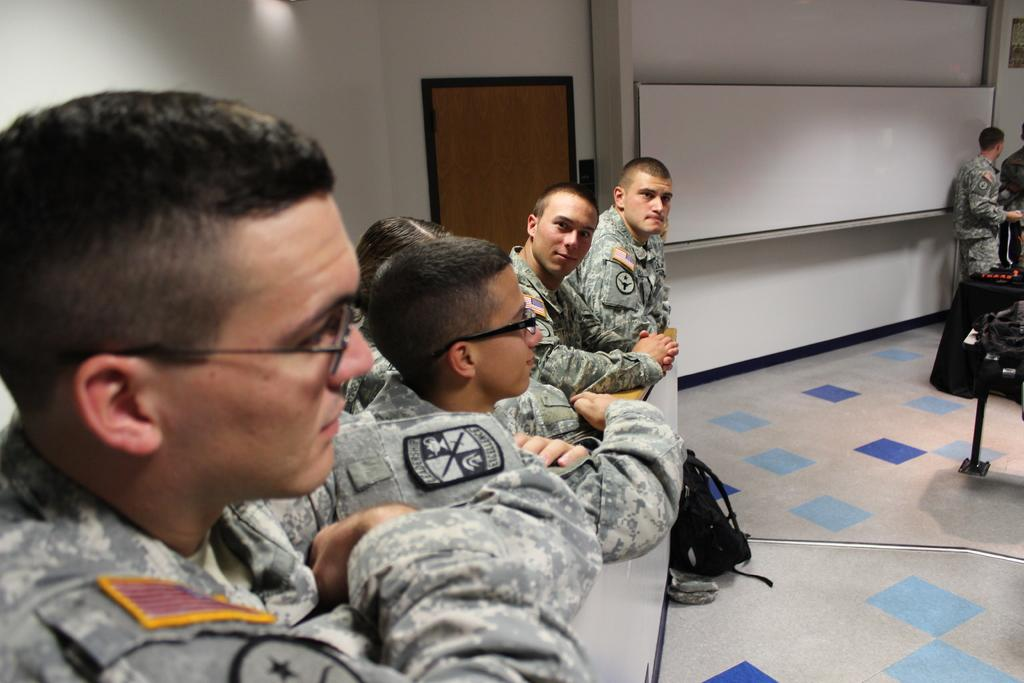What are the people in the image doing? The people in the image are standing near a wall. Can you describe the position of the person on the left side of the image? There is a person standing on the left side of the image. What can be seen in the background of the image? There is a wall, a door, and a whiteboard in the background of the image. What type of boot is the person on the left side of the image wearing? There is no information about the person's footwear in the image, so we cannot determine if they are wearing a boot or any other type of shoe. What is the person's belief about the whiteboard in the image? There is no information about the person's beliefs or thoughts in the image, so we cannot determine their opinion about the whiteboard. 